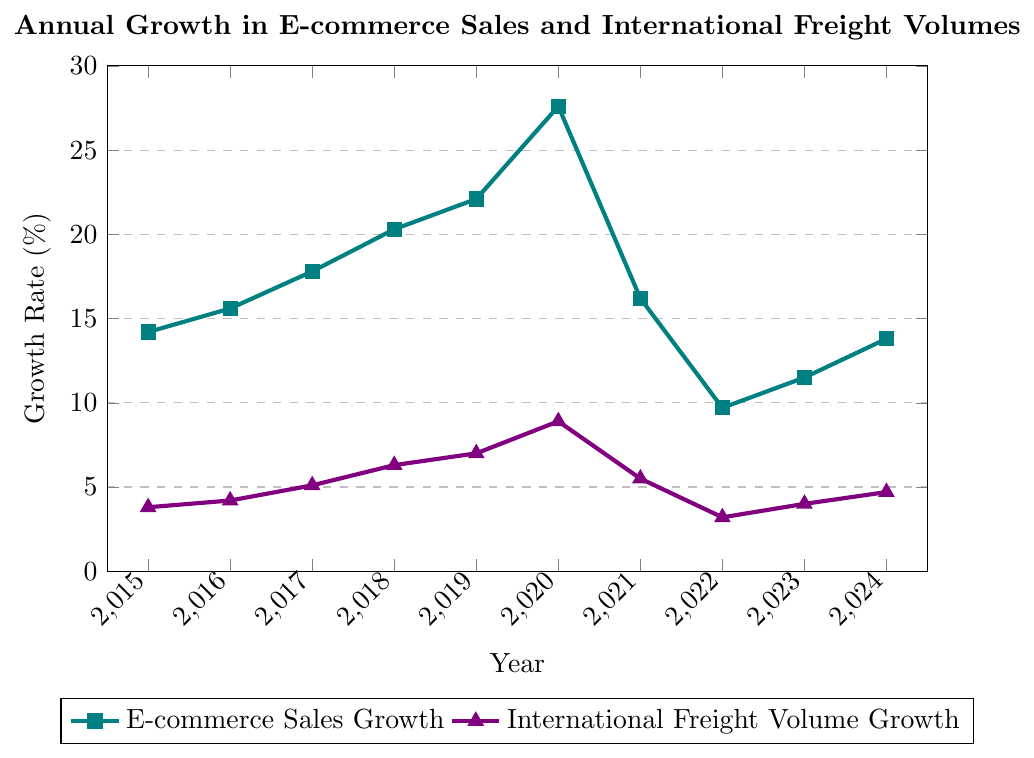What's the highest annual growth rate for e-commerce sales? Observing the figure, the highest point for the e-commerce sales growth line is in 2020, which corresponds to a growth rate of 27.6%.
Answer: 27.6% In which year did the international freight volume growth peak? Identifying the peak of the international freight volume growth line shows it occurred in 2020 with a growth rate of 8.9%.
Answer: 2020 What is the difference between e-commerce sales growth and international freight volume growth in 2020? The e-commerce sales growth is 27.6% and international freight volume growth is 8.9% in 2020. The difference is 27.6% - 8.9% = 18.7%.
Answer: 18.7% Which years saw both e-commerce sales growth and international freight volume growth increase? By examining the lines, both e-commerce sales growth and international freight volume growth increased in the years 2015, 2016, 2017, 2018, 2019, and 2020.
Answer: 2015, 2016, 2017, 2018, 2019, 2020 Compare the ratio of e-commerce sales growth to international freight volume growth from 2015 to 2024. In which year is this ratio the highest? Calculate the ratios for each year: 14.2/3.8 (2015), 15.6/4.2 (2016), 17.8/5.1 (2017), 20.3/6.3 (2018), 22.1/7.0 (2019), 27.6/8.9 (2020), 16.2/5.5 (2021), 9.7/3.2 (2022), 11.5/4.0 (2023), 13.8/4.7 (2024). The highest ratio is 27.6/8.9 in 2020.
Answer: 2020 What's the cumulative growth in international freight volumes from 2015 to 2024? Sum the international freight volume growth percentages from 2015 to 2024: 3.8 + 4.2 + 5.1 + 6.3 + 7.0 + 8.9 + 5.5 + 3.2 + 4.0 + 4.7 = 52.7%.
Answer: 52.7% Identify the trend for e-commerce sales growth between 2021 and 2024. Observing the e-commerce sales growth after 2021 shows it initially decreased in 2022 (9.7%), then increased again in 2023 (11.5%) and 2024 (13.8%).
Answer: Decreases in 2022, then increases in 2023 and 2024 What was the average annual growth rate for international freight volumes from 2015 to 2024? Calculate the sum of the annual growth rates for international freight volumes over the 10 years (52.7%) and divide by 10: 52.7/10 = 5.27%.
Answer: 5.27% Compare the growth trends in e-commerce sales and international freight volumes during 2021-2024. Both metrics declined in 2022. E-commerce growth increased again in 2023 and 2024, while freight volume growth also increased but more gradually.
Answer: Both decreased in 2022; e-commerce increased more sharply post-2022 During which years did e-commerce sales growth exceed 20%? The e-commerce sales growth exceeded 20% in the years 2018, 2019, and 2020.
Answer: 2018, 2019, 2020 